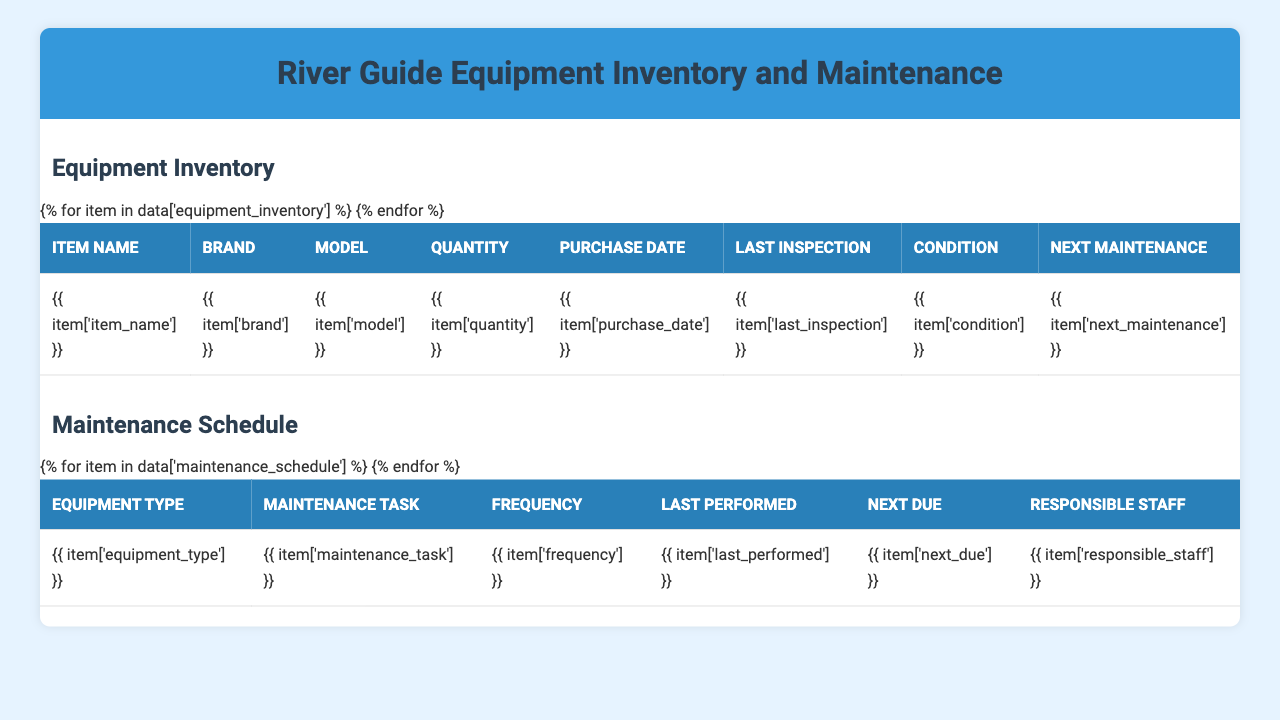What's the condition of the whitewater raft? In the equipment inventory table, the condition of the "Whitewater Raft" is listed as "Good."
Answer: Good How many life jackets are currently in inventory? The inventory shows that there are 50 "Life Jackets" available.
Answer: 50 When is the next maintenance due for paddles? The table indicates that the next maintenance for "Paddle" is due on "2023-10-01."
Answer: 2023-10-01 What is the maintenance frequency for helmets? The maintenance schedule specifies that the maintenance frequency for "Helmet" is "Monthly."
Answer: Monthly How many items have "Excellent" condition? In the inventory, there are 4 items marked as "Excellent": Paddle, Throw Bag, First Aid Kit, and Rescue Knife.
Answer: 4 What maintenance tasks are scheduled for next week? Next week, the following maintenance tasks are due: Life Jacket (2023-05-28), Paddle (2023-05-28), and Throw Bag (2023-06-01).
Answer: Life Jacket, Paddle, Throw Bag Which piece of equipment last had an inspection on April 20, 2023? The maintenance schedule shows that the "Helmet" had its last inspection on April 20, 2023.
Answer: Helmet What is the average quantity of equipment items in the inventory? The total quantity of equipment items is (8 + 40 + 50 + 30 + 15 + 10 + 60 + 20) = 233. There are 8 equipment types, so the average quantity is 233/8 = 29.125.
Answer: 29.125 Is the next maintenance for the Rescue Knife due before July 1, 2023? The next maintenance for the "Rescue Knife" is due on "2023-11-20," which is after July 1, 2023. Therefore, it's false.
Answer: No Which equipment has the earliest next maintenance date? Checking the "Next Maintenance" dates, the "Life Jacket" has the earliest next maintenance date of "2023-08-05."
Answer: Life Jacket How many different brands of equipment are listed in the inventory? The brands listed are NRS, Carlisle, Astral, Sweet Protection, Adventure Medical Kits, SealLine. There are 6 unique brands.
Answer: 6 